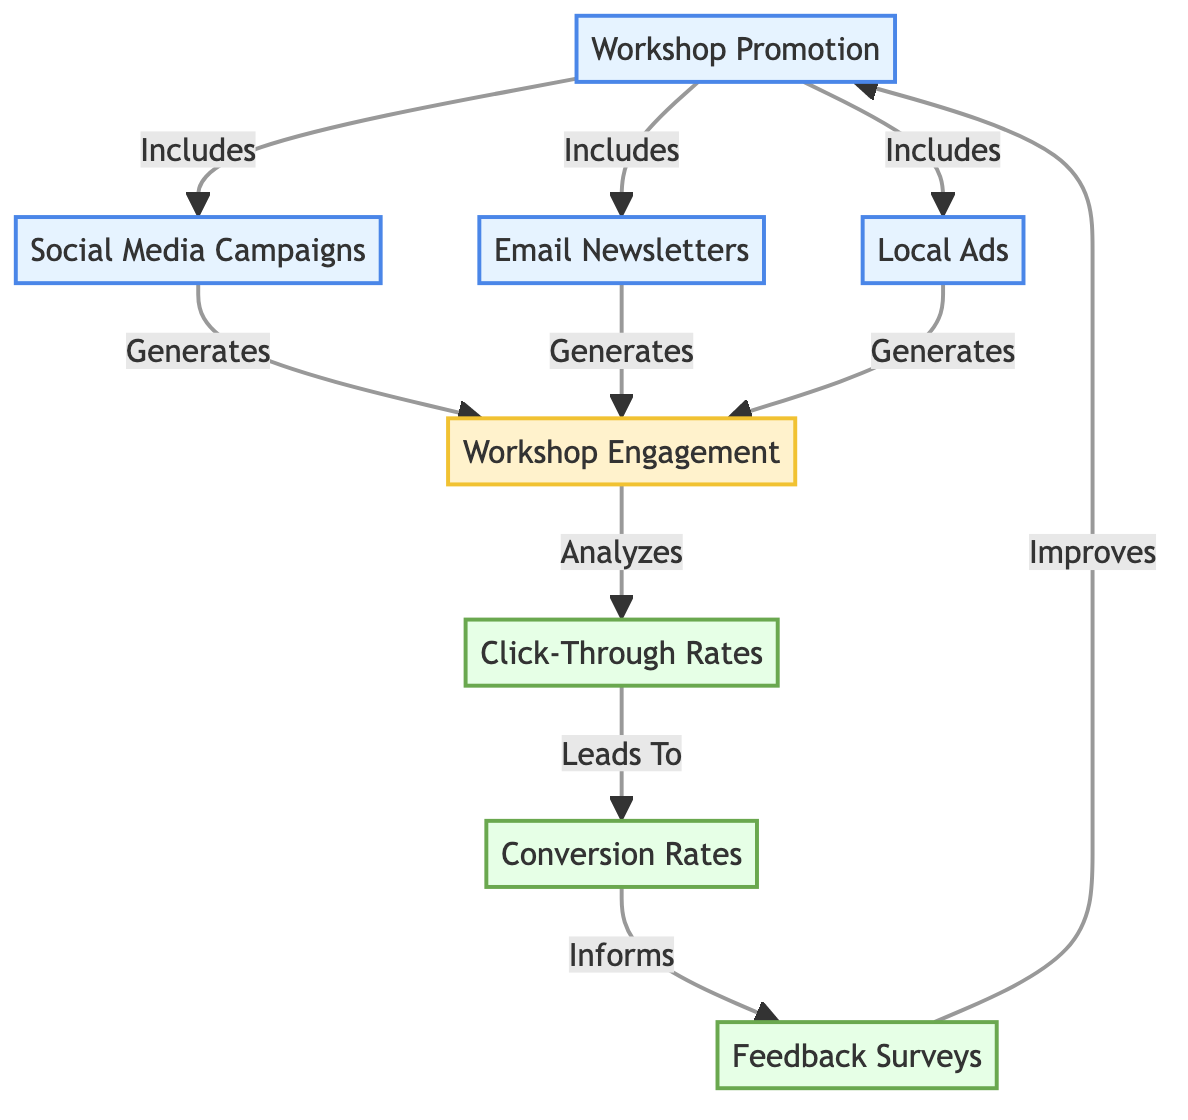What are the main components included in workshop promotion? The main components included in workshop promotion are social media campaigns, email newsletters, and local ads. These are directly linked to the workshop promotion node, indicating they are part of the overall strategy.
Answer: social media campaigns, email newsletters, local ads How many types of workshop engagement are generated from the promotions? The diagram shows a single node for workshop engagement, indicating that all promotional activities contribute to a collective form of engagement. There are no multiple engagement types listed, just a single engagement node.
Answer: 1 What is the first analysis produced from workshop engagement? The first analysis produced from workshop engagement is the click-through rates. This can be traced by following the arrows from the workshop engagement node to the respective analysis node it connects to.
Answer: click-through rates Which promotional activity is shown to generate workshop engagement? Social media campaigns, email newsletters, and local ads are all shown to generate workshop engagement, as indicated by their direct connections leading to the engagement node.
Answer: social media campaigns, email newsletters, local ads What informs the feedback surveys according to the diagram? The feedback surveys are informed by conversion rates, as indicated by the arrow leading from the conversion rates node to the feedback surveys node. This signifies that the conversion rates play a crucial role in shaping feedback collection efforts.
Answer: conversion rates What closes the feedback loop with workshop promotion? The feedback loop with workshop promotion is closed by the improvement of workshop promotion, as indicated by the arrow from feedback surveys back to workshop promotion, showing that insights can enhance future promotional efforts.
Answer: improves What do click-through rates lead to in the diagram? Click-through rates lead to conversion rates, as shown by the directed arrow indicating that analyzing click-through rates helps determine the subsequent conversion rates outcome.
Answer: conversion rates 